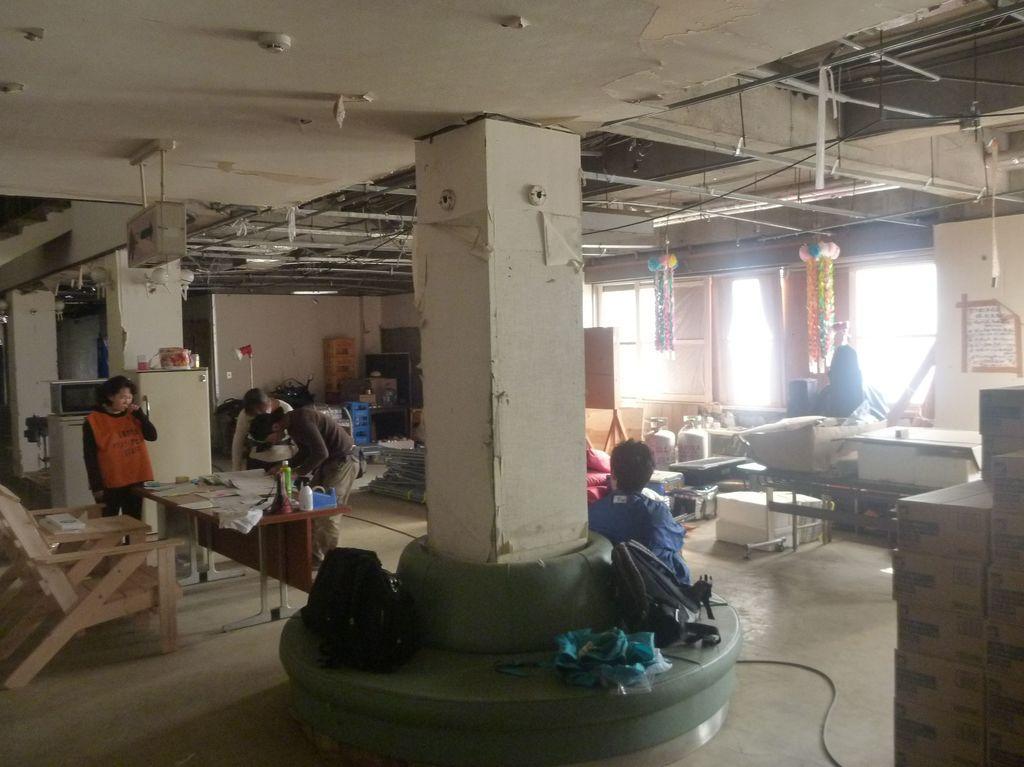How would you summarize this image in a sentence or two? In the middle of the image there are some bags. Behind the bag there is a man. Bottom left side of the image there is a chair and table, On the table there are some bottles and papers. Near to the table three men are standing. Behind them there is a there is a refrigerator. At the top of the image there is roof. In the middle of the image there is a window. Bottom right side of the image there are some bags. 